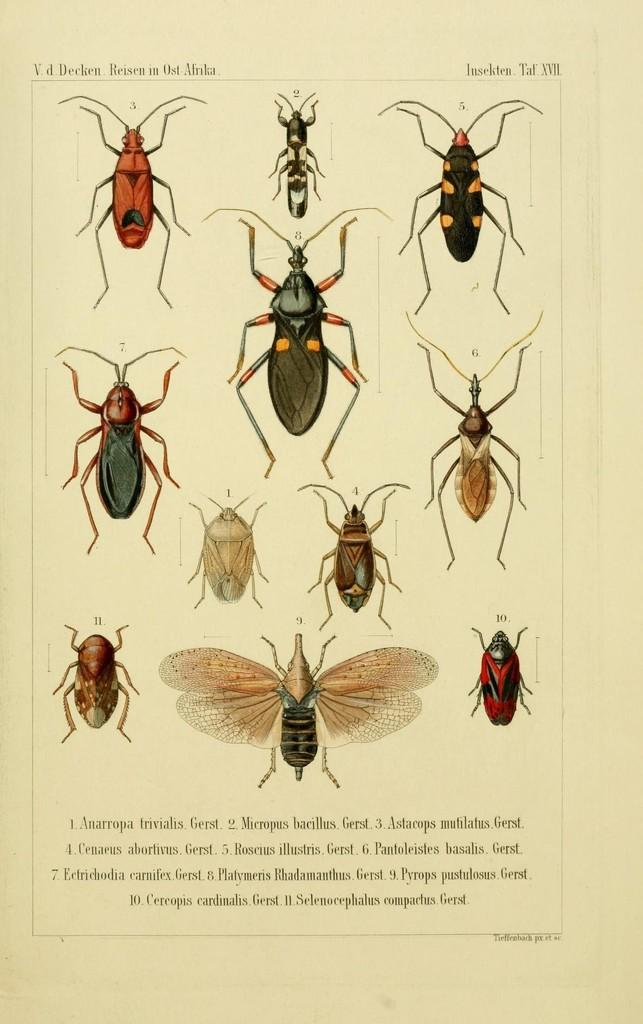What type of image is being described? The image is a poster. What is depicted on the poster? There are depictions of cockroaches on the poster. Are there any words on the poster? Yes, there is text on the poster. What type of fire can be seen burning in the background of the poster? There is no fire present in the image; it is a poster with depictions of cockroaches and text. 